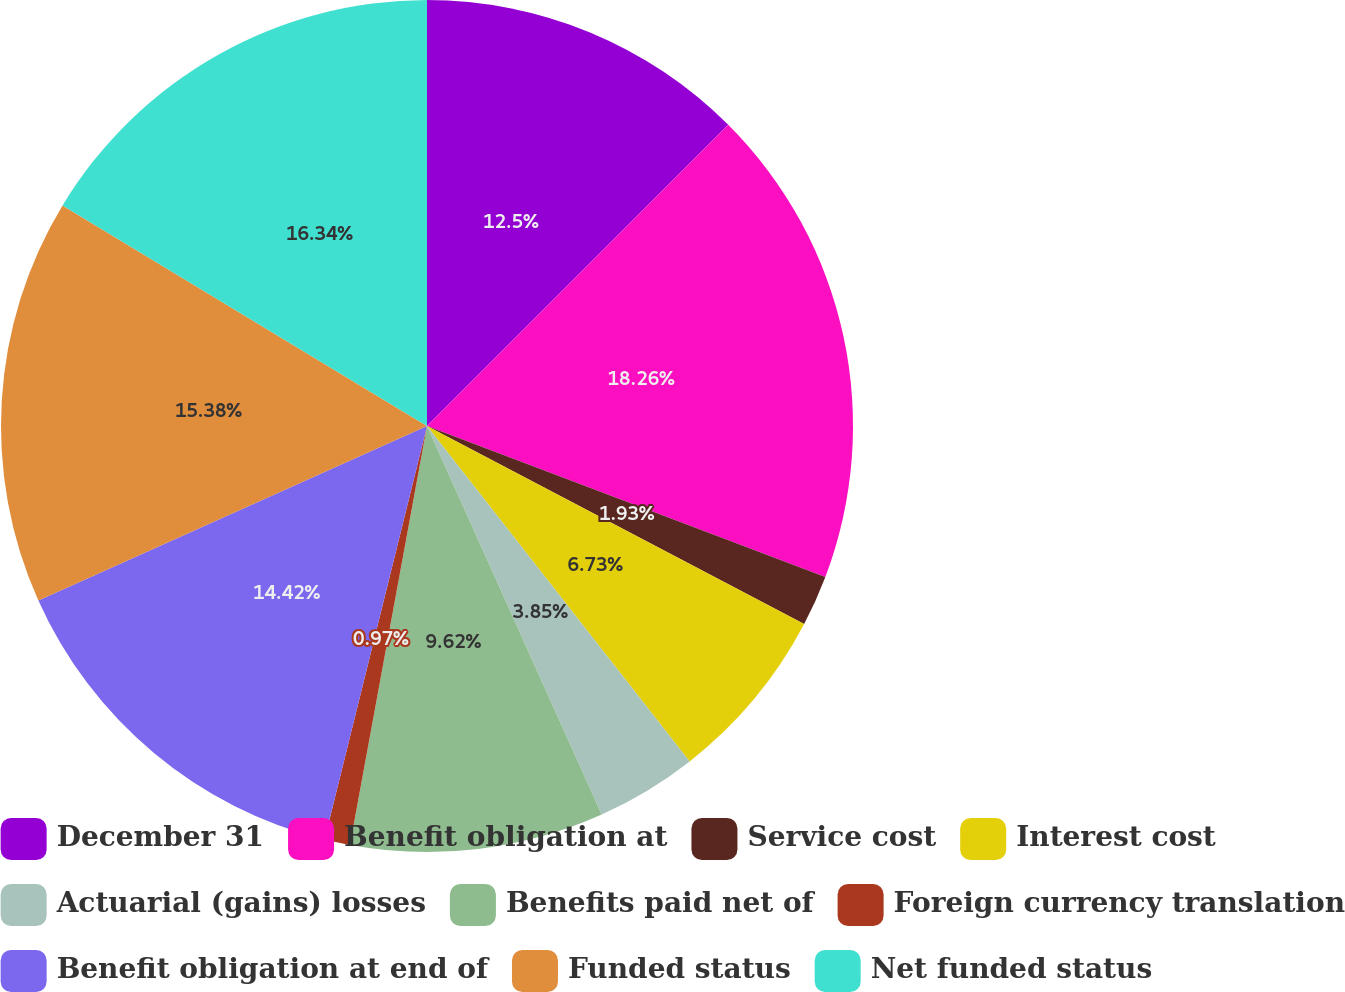Convert chart. <chart><loc_0><loc_0><loc_500><loc_500><pie_chart><fcel>December 31<fcel>Benefit obligation at<fcel>Service cost<fcel>Interest cost<fcel>Actuarial (gains) losses<fcel>Benefits paid net of<fcel>Foreign currency translation<fcel>Benefit obligation at end of<fcel>Funded status<fcel>Net funded status<nl><fcel>12.5%<fcel>18.27%<fcel>1.93%<fcel>6.73%<fcel>3.85%<fcel>9.62%<fcel>0.97%<fcel>14.42%<fcel>15.38%<fcel>16.34%<nl></chart> 